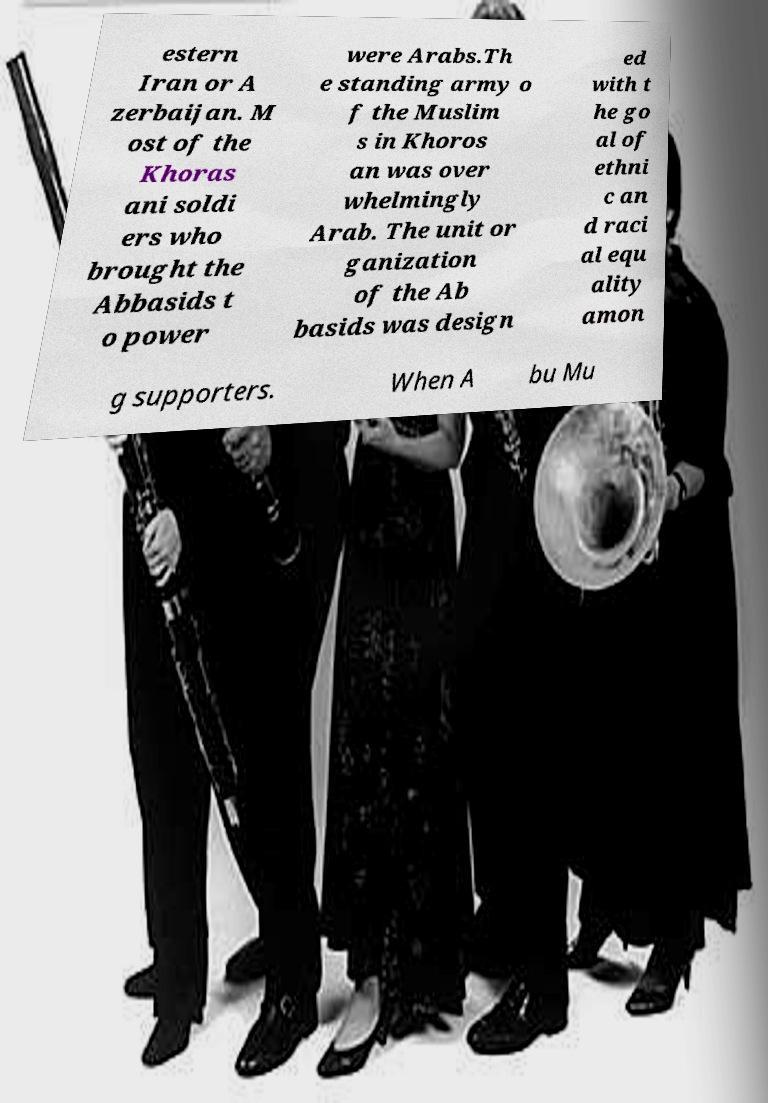What messages or text are displayed in this image? I need them in a readable, typed format. estern Iran or A zerbaijan. M ost of the Khoras ani soldi ers who brought the Abbasids t o power were Arabs.Th e standing army o f the Muslim s in Khoros an was over whelmingly Arab. The unit or ganization of the Ab basids was design ed with t he go al of ethni c an d raci al equ ality amon g supporters. When A bu Mu 